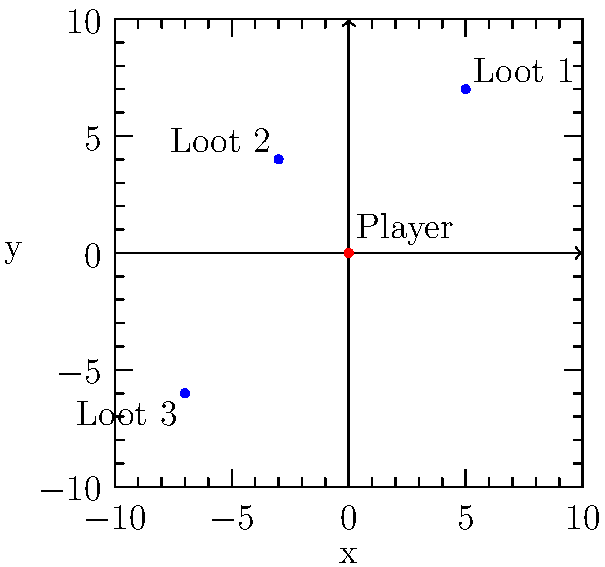In a disappointing match of your favorite battle royale game, you find yourself at the origin (0, 0) on the map. Three loot drops have appeared at the following coordinates: Loot 1 (5, 7), Loot 2 (-3, 4), and Loot 3 (-7, -6). Determine which loot drop is closest to your current position and calculate its distance from you. To find the closest loot drop and its distance, we need to calculate the distance between the player's position (0, 0) and each loot drop using the distance formula:

$d = \sqrt{(x_2 - x_1)^2 + (y_2 - y_1)^2}$

Step 1: Calculate the distance to Loot 1 (5, 7)
$d_1 = \sqrt{(5 - 0)^2 + (7 - 0)^2} = \sqrt{25 + 49} = \sqrt{74} \approx 8.60$ units

Step 2: Calculate the distance to Loot 2 (-3, 4)
$d_2 = \sqrt{(-3 - 0)^2 + (4 - 0)^2} = \sqrt{9 + 16} = \sqrt{25} = 5$ units

Step 3: Calculate the distance to Loot 3 (-7, -6)
$d_3 = \sqrt{(-7 - 0)^2 + (-6 - 0)^2} = \sqrt{49 + 36} = \sqrt{85} \approx 9.22$ units

Step 4: Compare the distances
$d_2 < d_1 < d_3$

Therefore, Loot 2 is the closest to the player's position, with a distance of 5 units.
Answer: Loot 2; 5 units 